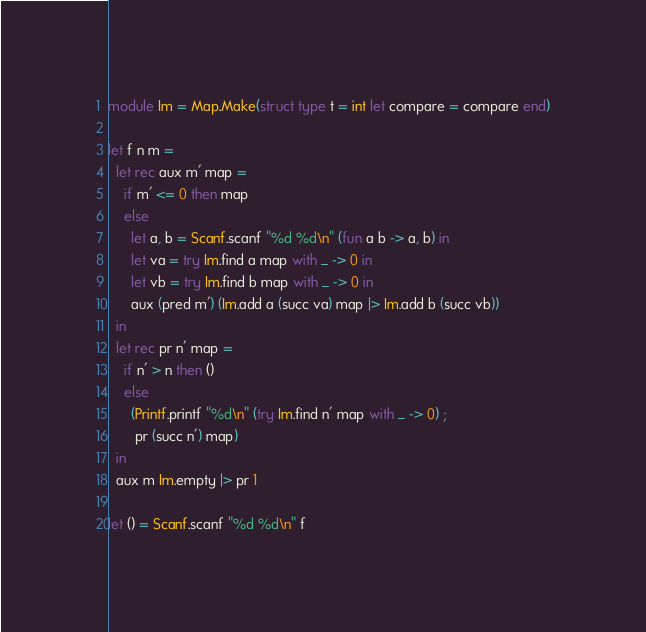<code> <loc_0><loc_0><loc_500><loc_500><_OCaml_>module Im = Map.Make(struct type t = int let compare = compare end)

let f n m =
  let rec aux m' map =
    if m' <= 0 then map
    else
      let a, b = Scanf.scanf "%d %d\n" (fun a b -> a, b) in
      let va = try Im.find a map with _ -> 0 in
      let vb = try Im.find b map with _ -> 0 in
      aux (pred m') (Im.add a (succ va) map |> Im.add b (succ vb))
  in
  let rec pr n' map =
    if n' > n then ()
    else
      (Printf.printf "%d\n" (try Im.find n' map with _ -> 0) ;
       pr (succ n') map)
  in
  aux m Im.empty |> pr 1

let () = Scanf.scanf "%d %d\n" f</code> 